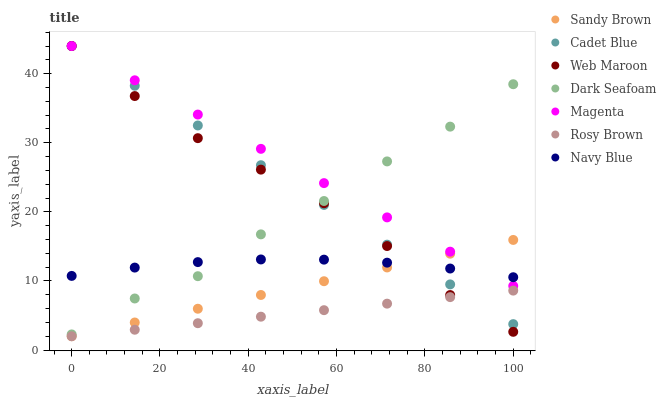Does Rosy Brown have the minimum area under the curve?
Answer yes or no. Yes. Does Magenta have the maximum area under the curve?
Answer yes or no. Yes. Does Navy Blue have the minimum area under the curve?
Answer yes or no. No. Does Navy Blue have the maximum area under the curve?
Answer yes or no. No. Is Rosy Brown the smoothest?
Answer yes or no. Yes. Is Dark Seafoam the roughest?
Answer yes or no. Yes. Is Navy Blue the smoothest?
Answer yes or no. No. Is Navy Blue the roughest?
Answer yes or no. No. Does Rosy Brown have the lowest value?
Answer yes or no. Yes. Does Navy Blue have the lowest value?
Answer yes or no. No. Does Magenta have the highest value?
Answer yes or no. Yes. Does Navy Blue have the highest value?
Answer yes or no. No. Is Rosy Brown less than Dark Seafoam?
Answer yes or no. Yes. Is Magenta greater than Rosy Brown?
Answer yes or no. Yes. Does Magenta intersect Dark Seafoam?
Answer yes or no. Yes. Is Magenta less than Dark Seafoam?
Answer yes or no. No. Is Magenta greater than Dark Seafoam?
Answer yes or no. No. Does Rosy Brown intersect Dark Seafoam?
Answer yes or no. No. 